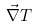Convert formula to latex. <formula><loc_0><loc_0><loc_500><loc_500>\vec { \nabla } T</formula> 